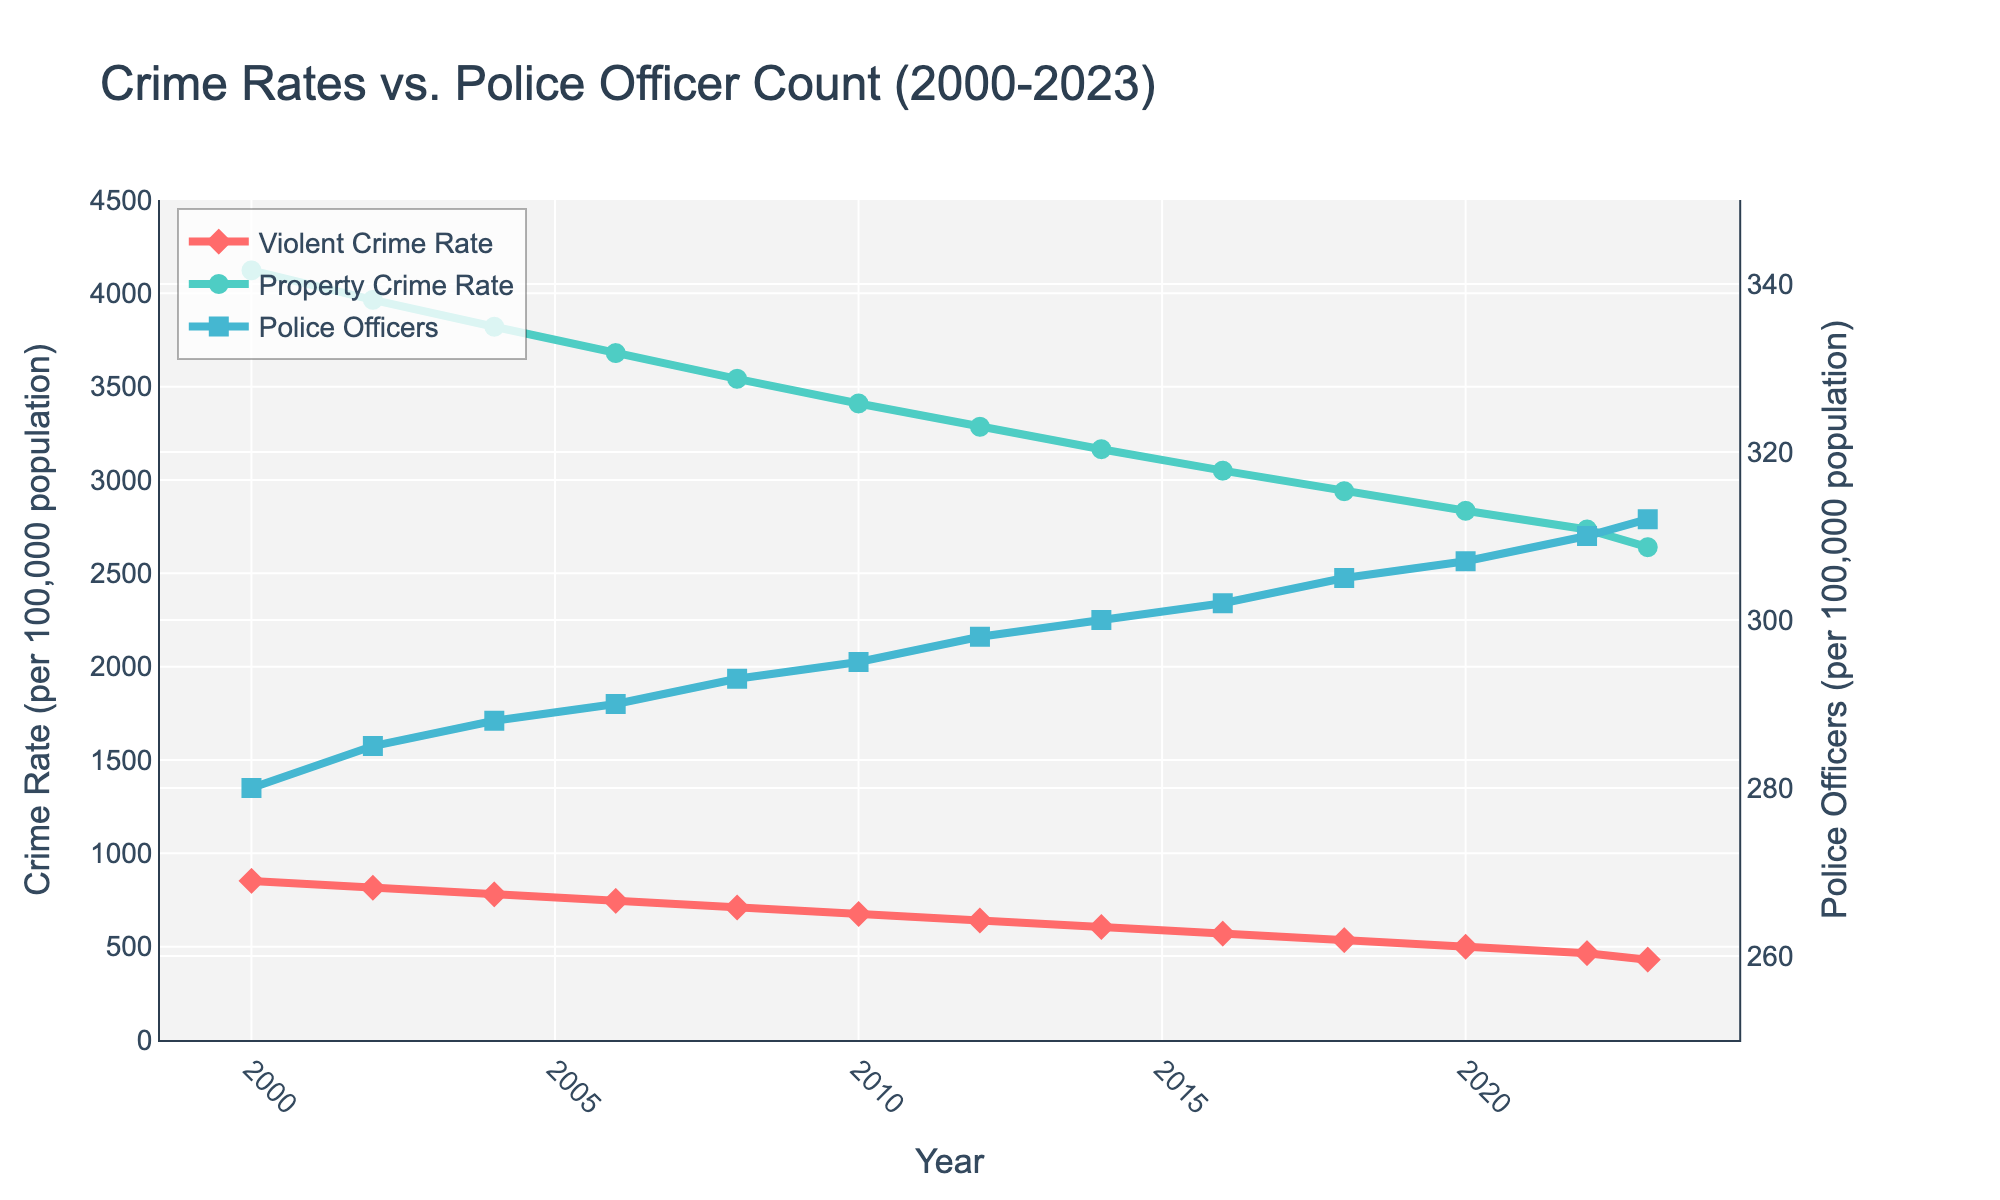What was the trend of the Violent Crime Rate from 2000 to 2023? The trend can be observed by looking at the line representing the Violent Crime Rate. The rate starts at 852 in 2000 and shows a consistent decline until it reaches 430 in 2023.
Answer: Decreasing In which year did the number of Police Officers per 100k surpass 300? The line representing Police Officers crosses the 300 mark between 2012 and 2014, finally surpassing it in 2014 with 300 officers.
Answer: 2014 By how much did the Property Crime Rate decrease from 2000 to 2023? The Property Crime Rate was 4123 in 2000 and dropped to 2640 in 2023. The decrease can be calculated as 4123 - 2640.
Answer: 1483 Is the general trend in the Police Officer count positively correlated with the Crime Rates? To determine if there is a positive correlation, one should look at the trends. Here, the Police Officers count is consistently increasing, while both the Violent and Property Crime Rates are consistently decreasing, suggesting a negative correlation.
Answer: No What year had the lowest Violent Crime Rate, and what was the rate? Observing the line for Violent Crime Rate, the lowest point is reached in 2023 with a rate of 430 per 100k.
Answer: 2023 and 430 Which year saw the most significant reduction in Property Crime Rate compared to its previous year? By analyzing the differences between consecutive years, the largest drop is between 2000 (4123) to 2002 (3965), a reduction of 158.
Answer: 2000 to 2002 Calculate the average number of Police Officers per 100k from 2000 to 2023. Summing the counts from all years (280+285+288+290+293+295+298+300+302+305+307+310+312) and dividing by 13 gives the average: (3865 / 13).
Answer: 297 Do the crime rates appear to decrease with an increase in police officers? The graph shows an increasing trend in the number of police officers while both types of crime rates (Violent and Property) show a decreasing trend over the same period, implying a inverse relationship.
Answer: Yes Between which consecutive years did the Violent Crime Rate decrease the most? The largest decrease occurs between 2000 and 2002 where the rate dropped from 852 to 815, a decline of 37.
Answer: 2000 to 2002 